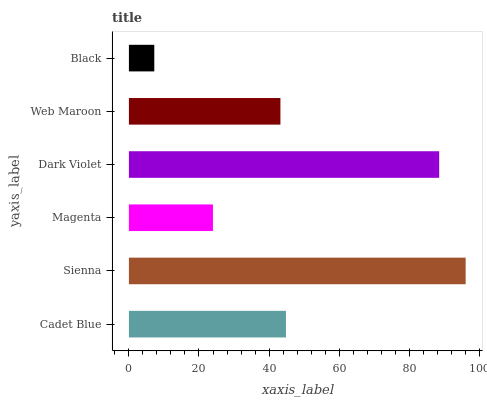Is Black the minimum?
Answer yes or no. Yes. Is Sienna the maximum?
Answer yes or no. Yes. Is Magenta the minimum?
Answer yes or no. No. Is Magenta the maximum?
Answer yes or no. No. Is Sienna greater than Magenta?
Answer yes or no. Yes. Is Magenta less than Sienna?
Answer yes or no. Yes. Is Magenta greater than Sienna?
Answer yes or no. No. Is Sienna less than Magenta?
Answer yes or no. No. Is Cadet Blue the high median?
Answer yes or no. Yes. Is Web Maroon the low median?
Answer yes or no. Yes. Is Sienna the high median?
Answer yes or no. No. Is Magenta the low median?
Answer yes or no. No. 